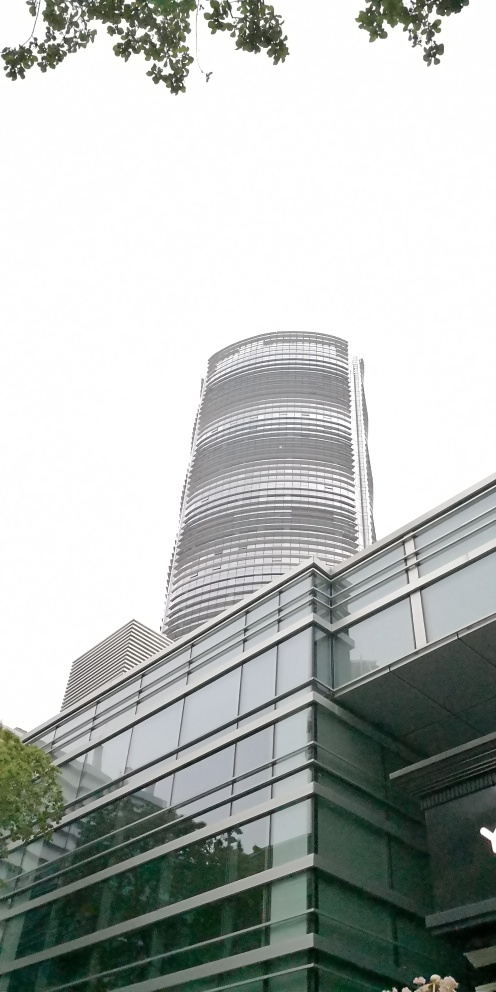Can you tell me about the weather conditions based on the picture? The sky in the background appears overcast, with no visible shadows on the building, which suggests that the weather is cloudy. The overall lighting is soft, lacking harsh sunlight, which is typical of an overcast day. 